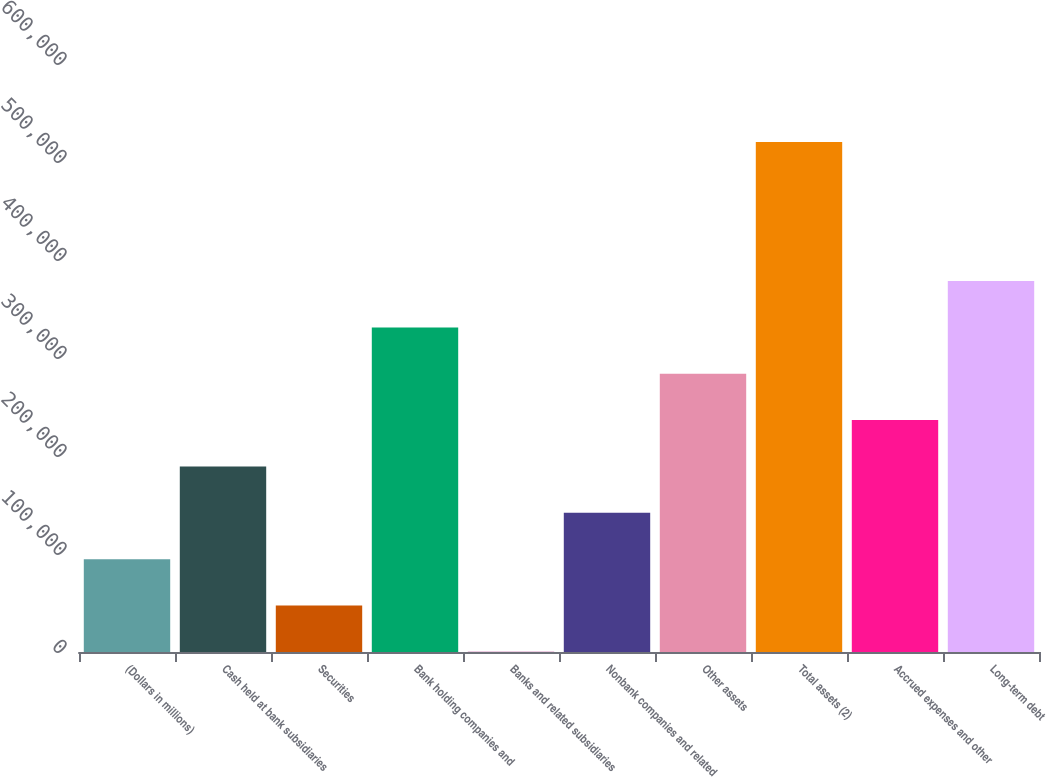Convert chart to OTSL. <chart><loc_0><loc_0><loc_500><loc_500><bar_chart><fcel>(Dollars in millions)<fcel>Cash held at bank subsidiaries<fcel>Securities<fcel>Bank holding companies and<fcel>Banks and related subsidiaries<fcel>Nonbank companies and related<fcel>Other assets<fcel>Total assets (2)<fcel>Accrued expenses and other<fcel>Long-term debt<nl><fcel>94733.8<fcel>189322<fcel>47439.9<fcel>331203<fcel>146<fcel>142028<fcel>283909<fcel>520379<fcel>236616<fcel>378497<nl></chart> 